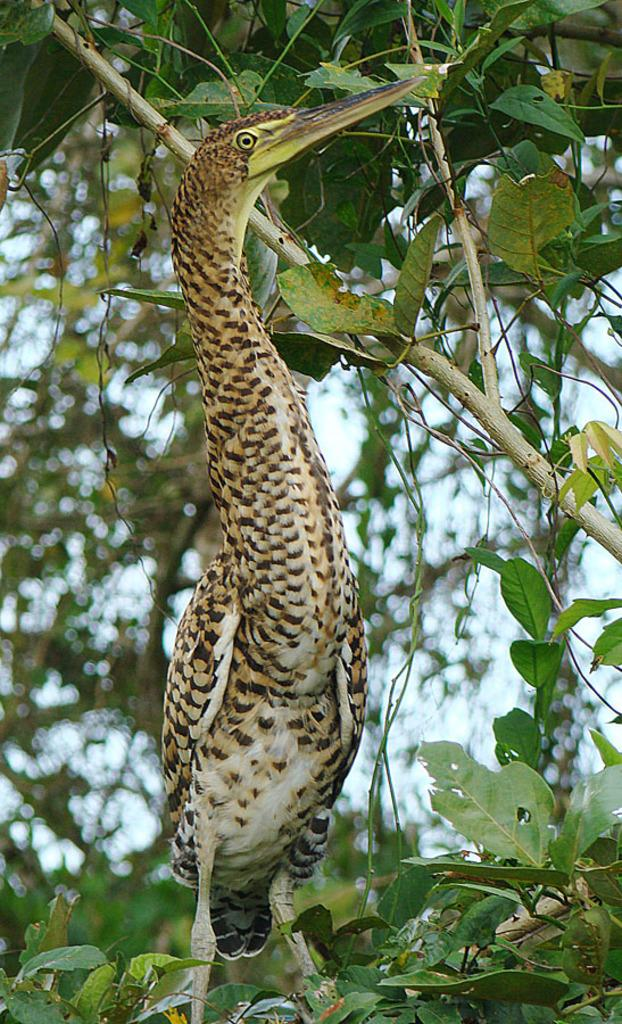What type of animal can be seen in the image? There is a bird in the image. What can be seen in the background of the image? There are trees and the sky visible in the background of the image. How does the bird provide support to the town in the image? There is no town present in the image, and the bird is not providing any support. 